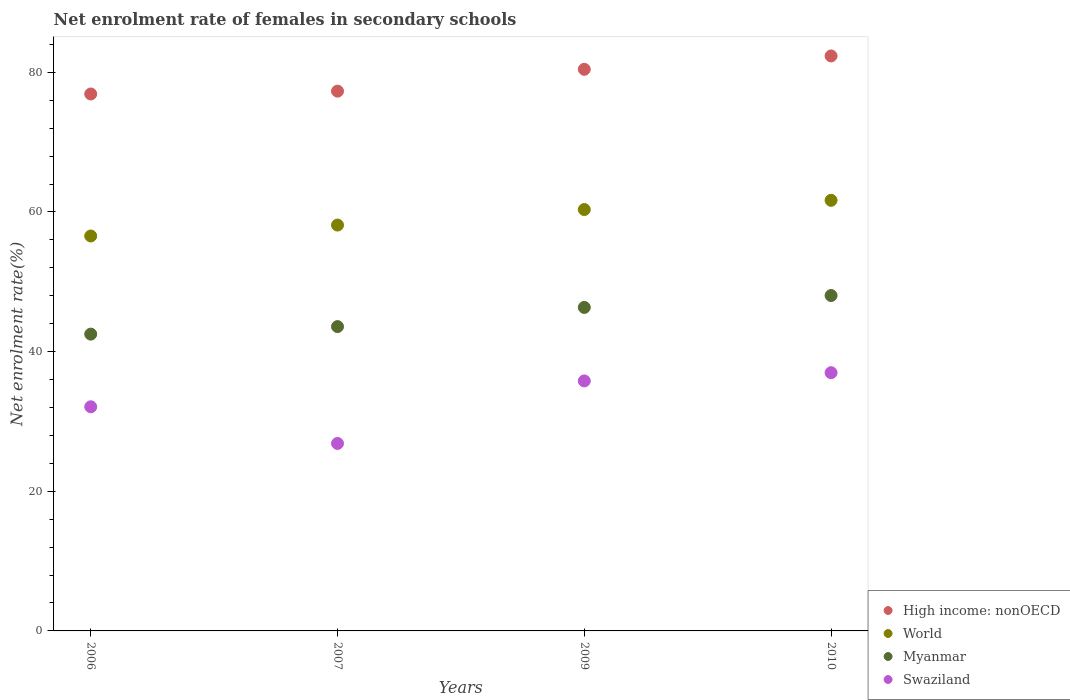How many different coloured dotlines are there?
Offer a very short reply. 4. Is the number of dotlines equal to the number of legend labels?
Provide a succinct answer. Yes. What is the net enrolment rate of females in secondary schools in Swaziland in 2006?
Make the answer very short. 32.1. Across all years, what is the maximum net enrolment rate of females in secondary schools in World?
Give a very brief answer. 61.67. Across all years, what is the minimum net enrolment rate of females in secondary schools in World?
Offer a terse response. 56.56. In which year was the net enrolment rate of females in secondary schools in Myanmar maximum?
Offer a very short reply. 2010. In which year was the net enrolment rate of females in secondary schools in World minimum?
Your answer should be compact. 2006. What is the total net enrolment rate of females in secondary schools in Myanmar in the graph?
Provide a short and direct response. 180.45. What is the difference between the net enrolment rate of females in secondary schools in Myanmar in 2006 and that in 2009?
Provide a succinct answer. -3.82. What is the difference between the net enrolment rate of females in secondary schools in High income: nonOECD in 2006 and the net enrolment rate of females in secondary schools in Swaziland in 2007?
Your answer should be compact. 50.05. What is the average net enrolment rate of females in secondary schools in Myanmar per year?
Your answer should be compact. 45.11. In the year 2007, what is the difference between the net enrolment rate of females in secondary schools in Myanmar and net enrolment rate of females in secondary schools in High income: nonOECD?
Give a very brief answer. -33.72. In how many years, is the net enrolment rate of females in secondary schools in Myanmar greater than 12 %?
Provide a succinct answer. 4. What is the ratio of the net enrolment rate of females in secondary schools in Myanmar in 2007 to that in 2009?
Offer a terse response. 0.94. What is the difference between the highest and the second highest net enrolment rate of females in secondary schools in High income: nonOECD?
Your response must be concise. 1.91. What is the difference between the highest and the lowest net enrolment rate of females in secondary schools in High income: nonOECD?
Keep it short and to the point. 5.45. Is the sum of the net enrolment rate of females in secondary schools in High income: nonOECD in 2006 and 2007 greater than the maximum net enrolment rate of females in secondary schools in Swaziland across all years?
Make the answer very short. Yes. Is it the case that in every year, the sum of the net enrolment rate of females in secondary schools in World and net enrolment rate of females in secondary schools in High income: nonOECD  is greater than the net enrolment rate of females in secondary schools in Swaziland?
Provide a succinct answer. Yes. Is the net enrolment rate of females in secondary schools in Myanmar strictly less than the net enrolment rate of females in secondary schools in World over the years?
Make the answer very short. Yes. How many dotlines are there?
Provide a short and direct response. 4. Where does the legend appear in the graph?
Ensure brevity in your answer.  Bottom right. What is the title of the graph?
Give a very brief answer. Net enrolment rate of females in secondary schools. What is the label or title of the Y-axis?
Your answer should be very brief. Net enrolment rate(%). What is the Net enrolment rate(%) in High income: nonOECD in 2006?
Ensure brevity in your answer.  76.9. What is the Net enrolment rate(%) of World in 2006?
Keep it short and to the point. 56.56. What is the Net enrolment rate(%) in Myanmar in 2006?
Offer a terse response. 42.51. What is the Net enrolment rate(%) of Swaziland in 2006?
Offer a very short reply. 32.1. What is the Net enrolment rate(%) in High income: nonOECD in 2007?
Your response must be concise. 77.3. What is the Net enrolment rate(%) of World in 2007?
Keep it short and to the point. 58.13. What is the Net enrolment rate(%) in Myanmar in 2007?
Offer a very short reply. 43.58. What is the Net enrolment rate(%) of Swaziland in 2007?
Make the answer very short. 26.85. What is the Net enrolment rate(%) in High income: nonOECD in 2009?
Offer a terse response. 80.43. What is the Net enrolment rate(%) in World in 2009?
Offer a very short reply. 60.35. What is the Net enrolment rate(%) in Myanmar in 2009?
Ensure brevity in your answer.  46.33. What is the Net enrolment rate(%) of Swaziland in 2009?
Your response must be concise. 35.8. What is the Net enrolment rate(%) in High income: nonOECD in 2010?
Provide a succinct answer. 82.34. What is the Net enrolment rate(%) in World in 2010?
Provide a short and direct response. 61.67. What is the Net enrolment rate(%) of Myanmar in 2010?
Provide a succinct answer. 48.03. What is the Net enrolment rate(%) of Swaziland in 2010?
Provide a short and direct response. 36.98. Across all years, what is the maximum Net enrolment rate(%) of High income: nonOECD?
Your answer should be very brief. 82.34. Across all years, what is the maximum Net enrolment rate(%) of World?
Give a very brief answer. 61.67. Across all years, what is the maximum Net enrolment rate(%) in Myanmar?
Ensure brevity in your answer.  48.03. Across all years, what is the maximum Net enrolment rate(%) of Swaziland?
Keep it short and to the point. 36.98. Across all years, what is the minimum Net enrolment rate(%) of High income: nonOECD?
Your answer should be compact. 76.9. Across all years, what is the minimum Net enrolment rate(%) in World?
Keep it short and to the point. 56.56. Across all years, what is the minimum Net enrolment rate(%) in Myanmar?
Make the answer very short. 42.51. Across all years, what is the minimum Net enrolment rate(%) of Swaziland?
Offer a terse response. 26.85. What is the total Net enrolment rate(%) of High income: nonOECD in the graph?
Keep it short and to the point. 316.98. What is the total Net enrolment rate(%) in World in the graph?
Make the answer very short. 236.7. What is the total Net enrolment rate(%) of Myanmar in the graph?
Your response must be concise. 180.45. What is the total Net enrolment rate(%) of Swaziland in the graph?
Ensure brevity in your answer.  131.73. What is the difference between the Net enrolment rate(%) in High income: nonOECD in 2006 and that in 2007?
Your answer should be very brief. -0.4. What is the difference between the Net enrolment rate(%) of World in 2006 and that in 2007?
Your answer should be compact. -1.57. What is the difference between the Net enrolment rate(%) of Myanmar in 2006 and that in 2007?
Give a very brief answer. -1.08. What is the difference between the Net enrolment rate(%) of Swaziland in 2006 and that in 2007?
Provide a short and direct response. 5.25. What is the difference between the Net enrolment rate(%) of High income: nonOECD in 2006 and that in 2009?
Your response must be concise. -3.53. What is the difference between the Net enrolment rate(%) of World in 2006 and that in 2009?
Ensure brevity in your answer.  -3.79. What is the difference between the Net enrolment rate(%) in Myanmar in 2006 and that in 2009?
Provide a short and direct response. -3.82. What is the difference between the Net enrolment rate(%) in Swaziland in 2006 and that in 2009?
Your answer should be compact. -3.7. What is the difference between the Net enrolment rate(%) of High income: nonOECD in 2006 and that in 2010?
Your answer should be compact. -5.45. What is the difference between the Net enrolment rate(%) in World in 2006 and that in 2010?
Provide a short and direct response. -5.11. What is the difference between the Net enrolment rate(%) of Myanmar in 2006 and that in 2010?
Give a very brief answer. -5.53. What is the difference between the Net enrolment rate(%) of Swaziland in 2006 and that in 2010?
Ensure brevity in your answer.  -4.88. What is the difference between the Net enrolment rate(%) in High income: nonOECD in 2007 and that in 2009?
Ensure brevity in your answer.  -3.13. What is the difference between the Net enrolment rate(%) in World in 2007 and that in 2009?
Make the answer very short. -2.22. What is the difference between the Net enrolment rate(%) of Myanmar in 2007 and that in 2009?
Your answer should be compact. -2.75. What is the difference between the Net enrolment rate(%) in Swaziland in 2007 and that in 2009?
Your answer should be very brief. -8.95. What is the difference between the Net enrolment rate(%) of High income: nonOECD in 2007 and that in 2010?
Give a very brief answer. -5.04. What is the difference between the Net enrolment rate(%) in World in 2007 and that in 2010?
Make the answer very short. -3.54. What is the difference between the Net enrolment rate(%) in Myanmar in 2007 and that in 2010?
Your answer should be compact. -4.45. What is the difference between the Net enrolment rate(%) in Swaziland in 2007 and that in 2010?
Provide a short and direct response. -10.13. What is the difference between the Net enrolment rate(%) in High income: nonOECD in 2009 and that in 2010?
Provide a succinct answer. -1.91. What is the difference between the Net enrolment rate(%) in World in 2009 and that in 2010?
Provide a succinct answer. -1.32. What is the difference between the Net enrolment rate(%) in Myanmar in 2009 and that in 2010?
Your answer should be compact. -1.7. What is the difference between the Net enrolment rate(%) of Swaziland in 2009 and that in 2010?
Your answer should be very brief. -1.18. What is the difference between the Net enrolment rate(%) of High income: nonOECD in 2006 and the Net enrolment rate(%) of World in 2007?
Provide a succinct answer. 18.77. What is the difference between the Net enrolment rate(%) of High income: nonOECD in 2006 and the Net enrolment rate(%) of Myanmar in 2007?
Give a very brief answer. 33.32. What is the difference between the Net enrolment rate(%) in High income: nonOECD in 2006 and the Net enrolment rate(%) in Swaziland in 2007?
Make the answer very short. 50.05. What is the difference between the Net enrolment rate(%) of World in 2006 and the Net enrolment rate(%) of Myanmar in 2007?
Your answer should be compact. 12.98. What is the difference between the Net enrolment rate(%) of World in 2006 and the Net enrolment rate(%) of Swaziland in 2007?
Provide a short and direct response. 29.71. What is the difference between the Net enrolment rate(%) of Myanmar in 2006 and the Net enrolment rate(%) of Swaziland in 2007?
Your response must be concise. 15.66. What is the difference between the Net enrolment rate(%) in High income: nonOECD in 2006 and the Net enrolment rate(%) in World in 2009?
Offer a terse response. 16.55. What is the difference between the Net enrolment rate(%) in High income: nonOECD in 2006 and the Net enrolment rate(%) in Myanmar in 2009?
Provide a succinct answer. 30.57. What is the difference between the Net enrolment rate(%) in High income: nonOECD in 2006 and the Net enrolment rate(%) in Swaziland in 2009?
Offer a very short reply. 41.09. What is the difference between the Net enrolment rate(%) of World in 2006 and the Net enrolment rate(%) of Myanmar in 2009?
Offer a very short reply. 10.23. What is the difference between the Net enrolment rate(%) in World in 2006 and the Net enrolment rate(%) in Swaziland in 2009?
Provide a short and direct response. 20.76. What is the difference between the Net enrolment rate(%) in Myanmar in 2006 and the Net enrolment rate(%) in Swaziland in 2009?
Provide a succinct answer. 6.7. What is the difference between the Net enrolment rate(%) of High income: nonOECD in 2006 and the Net enrolment rate(%) of World in 2010?
Give a very brief answer. 15.23. What is the difference between the Net enrolment rate(%) of High income: nonOECD in 2006 and the Net enrolment rate(%) of Myanmar in 2010?
Ensure brevity in your answer.  28.86. What is the difference between the Net enrolment rate(%) in High income: nonOECD in 2006 and the Net enrolment rate(%) in Swaziland in 2010?
Your response must be concise. 39.92. What is the difference between the Net enrolment rate(%) in World in 2006 and the Net enrolment rate(%) in Myanmar in 2010?
Your answer should be very brief. 8.53. What is the difference between the Net enrolment rate(%) of World in 2006 and the Net enrolment rate(%) of Swaziland in 2010?
Your response must be concise. 19.58. What is the difference between the Net enrolment rate(%) in Myanmar in 2006 and the Net enrolment rate(%) in Swaziland in 2010?
Offer a terse response. 5.52. What is the difference between the Net enrolment rate(%) of High income: nonOECD in 2007 and the Net enrolment rate(%) of World in 2009?
Provide a succinct answer. 16.96. What is the difference between the Net enrolment rate(%) of High income: nonOECD in 2007 and the Net enrolment rate(%) of Myanmar in 2009?
Give a very brief answer. 30.97. What is the difference between the Net enrolment rate(%) in High income: nonOECD in 2007 and the Net enrolment rate(%) in Swaziland in 2009?
Provide a short and direct response. 41.5. What is the difference between the Net enrolment rate(%) in World in 2007 and the Net enrolment rate(%) in Myanmar in 2009?
Offer a terse response. 11.8. What is the difference between the Net enrolment rate(%) of World in 2007 and the Net enrolment rate(%) of Swaziland in 2009?
Ensure brevity in your answer.  22.32. What is the difference between the Net enrolment rate(%) in Myanmar in 2007 and the Net enrolment rate(%) in Swaziland in 2009?
Provide a short and direct response. 7.78. What is the difference between the Net enrolment rate(%) of High income: nonOECD in 2007 and the Net enrolment rate(%) of World in 2010?
Your response must be concise. 15.63. What is the difference between the Net enrolment rate(%) in High income: nonOECD in 2007 and the Net enrolment rate(%) in Myanmar in 2010?
Offer a very short reply. 29.27. What is the difference between the Net enrolment rate(%) in High income: nonOECD in 2007 and the Net enrolment rate(%) in Swaziland in 2010?
Offer a very short reply. 40.32. What is the difference between the Net enrolment rate(%) in World in 2007 and the Net enrolment rate(%) in Myanmar in 2010?
Make the answer very short. 10.09. What is the difference between the Net enrolment rate(%) of World in 2007 and the Net enrolment rate(%) of Swaziland in 2010?
Make the answer very short. 21.14. What is the difference between the Net enrolment rate(%) in Myanmar in 2007 and the Net enrolment rate(%) in Swaziland in 2010?
Provide a short and direct response. 6.6. What is the difference between the Net enrolment rate(%) in High income: nonOECD in 2009 and the Net enrolment rate(%) in World in 2010?
Ensure brevity in your answer.  18.76. What is the difference between the Net enrolment rate(%) of High income: nonOECD in 2009 and the Net enrolment rate(%) of Myanmar in 2010?
Ensure brevity in your answer.  32.4. What is the difference between the Net enrolment rate(%) in High income: nonOECD in 2009 and the Net enrolment rate(%) in Swaziland in 2010?
Provide a succinct answer. 43.45. What is the difference between the Net enrolment rate(%) in World in 2009 and the Net enrolment rate(%) in Myanmar in 2010?
Offer a very short reply. 12.31. What is the difference between the Net enrolment rate(%) of World in 2009 and the Net enrolment rate(%) of Swaziland in 2010?
Make the answer very short. 23.37. What is the difference between the Net enrolment rate(%) in Myanmar in 2009 and the Net enrolment rate(%) in Swaziland in 2010?
Offer a terse response. 9.35. What is the average Net enrolment rate(%) of High income: nonOECD per year?
Your response must be concise. 79.24. What is the average Net enrolment rate(%) in World per year?
Make the answer very short. 59.18. What is the average Net enrolment rate(%) of Myanmar per year?
Make the answer very short. 45.11. What is the average Net enrolment rate(%) of Swaziland per year?
Make the answer very short. 32.93. In the year 2006, what is the difference between the Net enrolment rate(%) in High income: nonOECD and Net enrolment rate(%) in World?
Your answer should be compact. 20.34. In the year 2006, what is the difference between the Net enrolment rate(%) in High income: nonOECD and Net enrolment rate(%) in Myanmar?
Your response must be concise. 34.39. In the year 2006, what is the difference between the Net enrolment rate(%) in High income: nonOECD and Net enrolment rate(%) in Swaziland?
Provide a short and direct response. 44.8. In the year 2006, what is the difference between the Net enrolment rate(%) of World and Net enrolment rate(%) of Myanmar?
Make the answer very short. 14.05. In the year 2006, what is the difference between the Net enrolment rate(%) of World and Net enrolment rate(%) of Swaziland?
Your answer should be very brief. 24.46. In the year 2006, what is the difference between the Net enrolment rate(%) in Myanmar and Net enrolment rate(%) in Swaziland?
Give a very brief answer. 10.41. In the year 2007, what is the difference between the Net enrolment rate(%) in High income: nonOECD and Net enrolment rate(%) in World?
Provide a short and direct response. 19.18. In the year 2007, what is the difference between the Net enrolment rate(%) of High income: nonOECD and Net enrolment rate(%) of Myanmar?
Make the answer very short. 33.72. In the year 2007, what is the difference between the Net enrolment rate(%) of High income: nonOECD and Net enrolment rate(%) of Swaziland?
Your answer should be compact. 50.45. In the year 2007, what is the difference between the Net enrolment rate(%) of World and Net enrolment rate(%) of Myanmar?
Make the answer very short. 14.54. In the year 2007, what is the difference between the Net enrolment rate(%) of World and Net enrolment rate(%) of Swaziland?
Your response must be concise. 31.28. In the year 2007, what is the difference between the Net enrolment rate(%) of Myanmar and Net enrolment rate(%) of Swaziland?
Keep it short and to the point. 16.73. In the year 2009, what is the difference between the Net enrolment rate(%) of High income: nonOECD and Net enrolment rate(%) of World?
Provide a short and direct response. 20.08. In the year 2009, what is the difference between the Net enrolment rate(%) of High income: nonOECD and Net enrolment rate(%) of Myanmar?
Keep it short and to the point. 34.1. In the year 2009, what is the difference between the Net enrolment rate(%) of High income: nonOECD and Net enrolment rate(%) of Swaziland?
Provide a succinct answer. 44.63. In the year 2009, what is the difference between the Net enrolment rate(%) in World and Net enrolment rate(%) in Myanmar?
Offer a very short reply. 14.02. In the year 2009, what is the difference between the Net enrolment rate(%) of World and Net enrolment rate(%) of Swaziland?
Provide a short and direct response. 24.54. In the year 2009, what is the difference between the Net enrolment rate(%) in Myanmar and Net enrolment rate(%) in Swaziland?
Provide a short and direct response. 10.53. In the year 2010, what is the difference between the Net enrolment rate(%) in High income: nonOECD and Net enrolment rate(%) in World?
Ensure brevity in your answer.  20.68. In the year 2010, what is the difference between the Net enrolment rate(%) in High income: nonOECD and Net enrolment rate(%) in Myanmar?
Your answer should be very brief. 34.31. In the year 2010, what is the difference between the Net enrolment rate(%) in High income: nonOECD and Net enrolment rate(%) in Swaziland?
Ensure brevity in your answer.  45.36. In the year 2010, what is the difference between the Net enrolment rate(%) of World and Net enrolment rate(%) of Myanmar?
Offer a very short reply. 13.64. In the year 2010, what is the difference between the Net enrolment rate(%) in World and Net enrolment rate(%) in Swaziland?
Your answer should be compact. 24.69. In the year 2010, what is the difference between the Net enrolment rate(%) of Myanmar and Net enrolment rate(%) of Swaziland?
Your answer should be compact. 11.05. What is the ratio of the Net enrolment rate(%) in High income: nonOECD in 2006 to that in 2007?
Offer a terse response. 0.99. What is the ratio of the Net enrolment rate(%) of World in 2006 to that in 2007?
Make the answer very short. 0.97. What is the ratio of the Net enrolment rate(%) in Myanmar in 2006 to that in 2007?
Provide a succinct answer. 0.98. What is the ratio of the Net enrolment rate(%) in Swaziland in 2006 to that in 2007?
Give a very brief answer. 1.2. What is the ratio of the Net enrolment rate(%) of High income: nonOECD in 2006 to that in 2009?
Provide a short and direct response. 0.96. What is the ratio of the Net enrolment rate(%) in World in 2006 to that in 2009?
Your answer should be compact. 0.94. What is the ratio of the Net enrolment rate(%) in Myanmar in 2006 to that in 2009?
Keep it short and to the point. 0.92. What is the ratio of the Net enrolment rate(%) of Swaziland in 2006 to that in 2009?
Ensure brevity in your answer.  0.9. What is the ratio of the Net enrolment rate(%) of High income: nonOECD in 2006 to that in 2010?
Make the answer very short. 0.93. What is the ratio of the Net enrolment rate(%) in World in 2006 to that in 2010?
Offer a very short reply. 0.92. What is the ratio of the Net enrolment rate(%) in Myanmar in 2006 to that in 2010?
Your answer should be very brief. 0.88. What is the ratio of the Net enrolment rate(%) of Swaziland in 2006 to that in 2010?
Your response must be concise. 0.87. What is the ratio of the Net enrolment rate(%) in High income: nonOECD in 2007 to that in 2009?
Ensure brevity in your answer.  0.96. What is the ratio of the Net enrolment rate(%) of World in 2007 to that in 2009?
Give a very brief answer. 0.96. What is the ratio of the Net enrolment rate(%) of Myanmar in 2007 to that in 2009?
Keep it short and to the point. 0.94. What is the ratio of the Net enrolment rate(%) of Swaziland in 2007 to that in 2009?
Your answer should be compact. 0.75. What is the ratio of the Net enrolment rate(%) in High income: nonOECD in 2007 to that in 2010?
Give a very brief answer. 0.94. What is the ratio of the Net enrolment rate(%) of World in 2007 to that in 2010?
Provide a succinct answer. 0.94. What is the ratio of the Net enrolment rate(%) of Myanmar in 2007 to that in 2010?
Ensure brevity in your answer.  0.91. What is the ratio of the Net enrolment rate(%) in Swaziland in 2007 to that in 2010?
Offer a very short reply. 0.73. What is the ratio of the Net enrolment rate(%) of High income: nonOECD in 2009 to that in 2010?
Your response must be concise. 0.98. What is the ratio of the Net enrolment rate(%) in World in 2009 to that in 2010?
Your answer should be very brief. 0.98. What is the ratio of the Net enrolment rate(%) in Myanmar in 2009 to that in 2010?
Your answer should be compact. 0.96. What is the ratio of the Net enrolment rate(%) of Swaziland in 2009 to that in 2010?
Make the answer very short. 0.97. What is the difference between the highest and the second highest Net enrolment rate(%) in High income: nonOECD?
Give a very brief answer. 1.91. What is the difference between the highest and the second highest Net enrolment rate(%) in World?
Your response must be concise. 1.32. What is the difference between the highest and the second highest Net enrolment rate(%) of Myanmar?
Provide a short and direct response. 1.7. What is the difference between the highest and the second highest Net enrolment rate(%) in Swaziland?
Provide a succinct answer. 1.18. What is the difference between the highest and the lowest Net enrolment rate(%) of High income: nonOECD?
Your response must be concise. 5.45. What is the difference between the highest and the lowest Net enrolment rate(%) in World?
Provide a short and direct response. 5.11. What is the difference between the highest and the lowest Net enrolment rate(%) of Myanmar?
Offer a terse response. 5.53. What is the difference between the highest and the lowest Net enrolment rate(%) in Swaziland?
Your answer should be very brief. 10.13. 